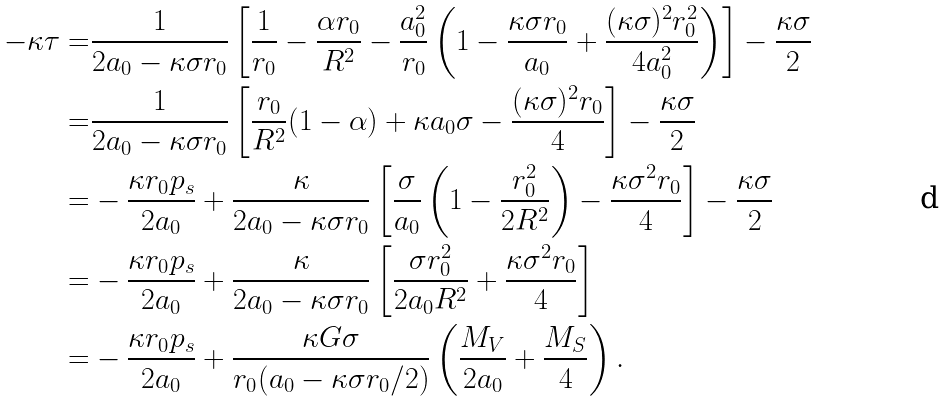Convert formula to latex. <formula><loc_0><loc_0><loc_500><loc_500>- \kappa \tau = & \frac { 1 } { 2 a _ { 0 } - \kappa \sigma r _ { 0 } } \left [ \frac { 1 } { r _ { 0 } } - \frac { \alpha r _ { 0 } } { R ^ { 2 } } - \frac { a _ { 0 } ^ { 2 } } { r _ { 0 } } \left ( 1 - \frac { \kappa \sigma r _ { 0 } } { a _ { 0 } } + \frac { ( \kappa \sigma ) ^ { 2 } r _ { 0 } ^ { 2 } } { 4 a _ { 0 } ^ { 2 } } \right ) \right ] - \frac { \kappa \sigma } { 2 } \\ = & \frac { 1 } { 2 a _ { 0 } - \kappa \sigma r _ { 0 } } \left [ \frac { r _ { 0 } } { R ^ { 2 } } ( 1 - \alpha ) + \kappa a _ { 0 } \sigma - \frac { ( \kappa \sigma ) ^ { 2 } r _ { 0 } } { 4 } \right ] - \frac { \kappa \sigma } { 2 } \\ = & - \frac { \kappa r _ { 0 } p _ { s } } { 2 a _ { 0 } } + \frac { \kappa } { 2 a _ { 0 } - \kappa \sigma r _ { 0 } } \left [ \frac { \sigma } { a _ { 0 } } \left ( 1 - \frac { r _ { 0 } ^ { 2 } } { 2 R ^ { 2 } } \right ) - \frac { \kappa \sigma ^ { 2 } r _ { 0 } } { 4 } \right ] - \frac { \kappa \sigma } { 2 } \\ = & - \frac { \kappa r _ { 0 } p _ { s } } { 2 a _ { 0 } } + \frac { \kappa } { 2 a _ { 0 } - \kappa \sigma r _ { 0 } } \left [ \frac { \sigma r _ { 0 } ^ { 2 } } { 2 a _ { 0 } R ^ { 2 } } + \frac { \kappa \sigma ^ { 2 } r _ { 0 } } { 4 } \right ] \\ = & - \frac { \kappa r _ { 0 } p _ { s } } { 2 a _ { 0 } } + \frac { \kappa G \sigma } { r _ { 0 } ( a _ { 0 } - \kappa \sigma r _ { 0 } / 2 ) } \left ( \frac { M _ { V } } { 2 a _ { 0 } } + \frac { M _ { S } } { 4 } \right ) .</formula> 